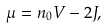Convert formula to latex. <formula><loc_0><loc_0><loc_500><loc_500>\mu = n _ { 0 } V - 2 J ,</formula> 